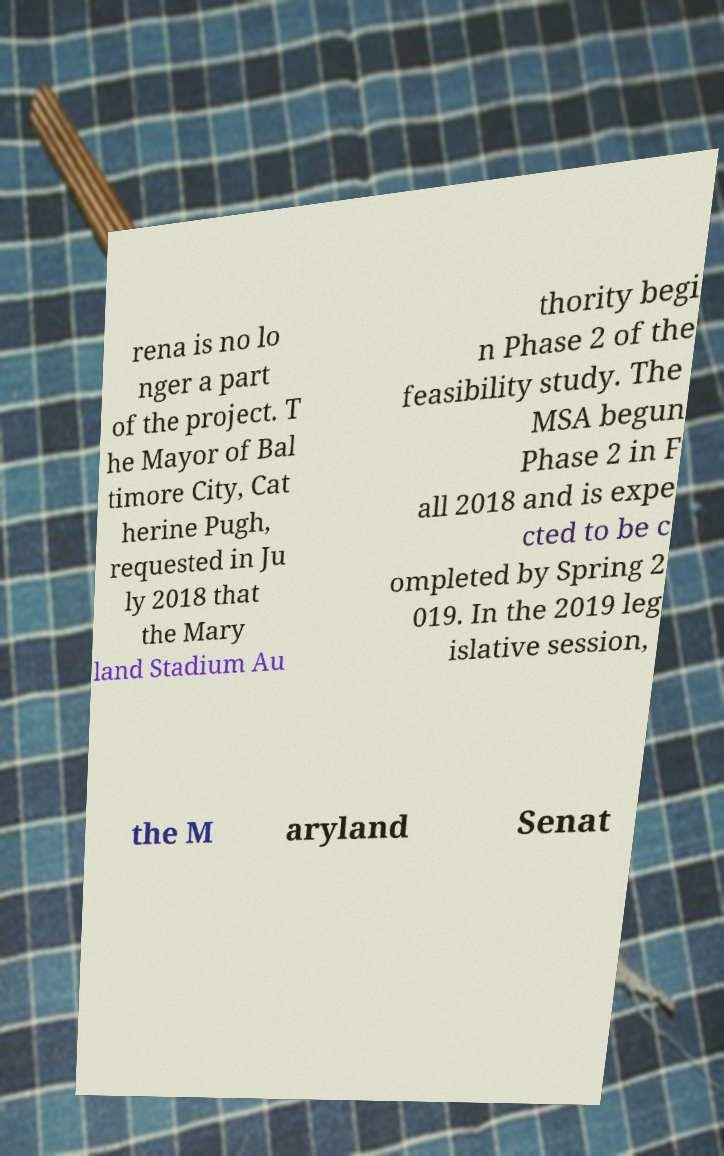Can you accurately transcribe the text from the provided image for me? rena is no lo nger a part of the project. T he Mayor of Bal timore City, Cat herine Pugh, requested in Ju ly 2018 that the Mary land Stadium Au thority begi n Phase 2 of the feasibility study. The MSA begun Phase 2 in F all 2018 and is expe cted to be c ompleted by Spring 2 019. In the 2019 leg islative session, the M aryland Senat 